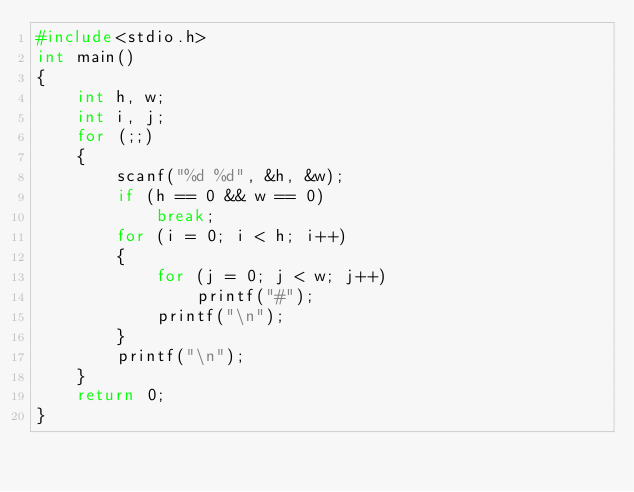<code> <loc_0><loc_0><loc_500><loc_500><_C_>#include<stdio.h>
int main()
{
	int h, w;
	int i, j;
	for (;;)
	{
		scanf("%d %d", &h, &w);
		if (h == 0 && w == 0)
			break;
		for (i = 0; i < h; i++)
		{
			for (j = 0; j < w; j++)
				printf("#");
			printf("\n");
		}
		printf("\n");
	}
	return 0;
}
</code> 